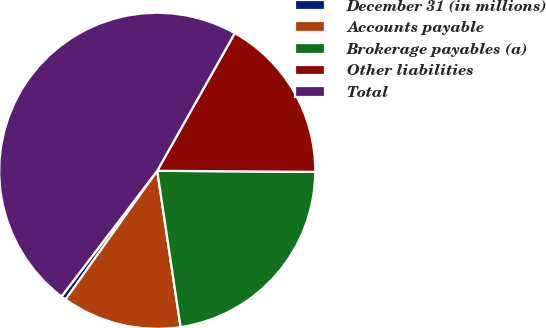Convert chart to OTSL. <chart><loc_0><loc_0><loc_500><loc_500><pie_chart><fcel>December 31 (in millions)<fcel>Accounts payable<fcel>Brokerage payables (a)<fcel>Other liabilities<fcel>Total<nl><fcel>0.51%<fcel>12.21%<fcel>22.53%<fcel>16.94%<fcel>47.81%<nl></chart> 